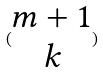<formula> <loc_0><loc_0><loc_500><loc_500>( \begin{matrix} m + 1 \\ k \end{matrix} )</formula> 